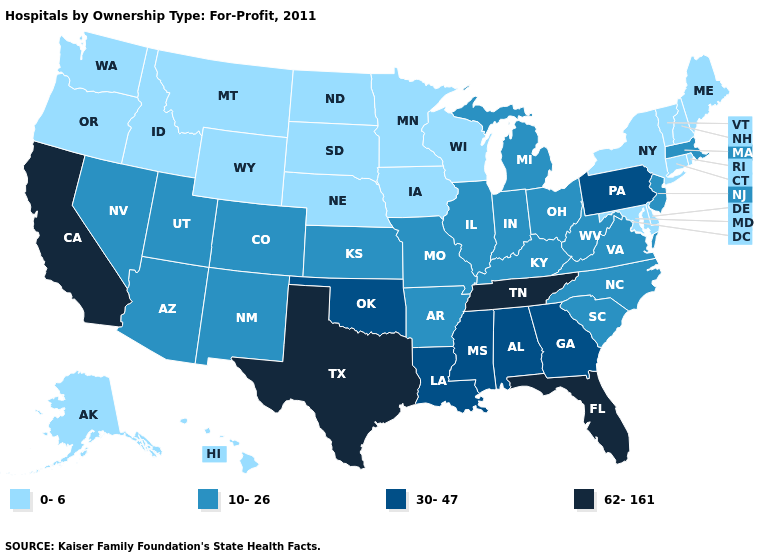Does Texas have the highest value in the USA?
Quick response, please. Yes. Name the states that have a value in the range 30-47?
Concise answer only. Alabama, Georgia, Louisiana, Mississippi, Oklahoma, Pennsylvania. Name the states that have a value in the range 62-161?
Keep it brief. California, Florida, Tennessee, Texas. What is the lowest value in the West?
Keep it brief. 0-6. What is the value of Maine?
Be succinct. 0-6. Is the legend a continuous bar?
Be succinct. No. Does the first symbol in the legend represent the smallest category?
Be succinct. Yes. Which states have the lowest value in the USA?
Quick response, please. Alaska, Connecticut, Delaware, Hawaii, Idaho, Iowa, Maine, Maryland, Minnesota, Montana, Nebraska, New Hampshire, New York, North Dakota, Oregon, Rhode Island, South Dakota, Vermont, Washington, Wisconsin, Wyoming. Does West Virginia have a lower value than Delaware?
Keep it brief. No. Is the legend a continuous bar?
Keep it brief. No. What is the value of Florida?
Concise answer only. 62-161. Does Idaho have the lowest value in the USA?
Be succinct. Yes. Name the states that have a value in the range 10-26?
Write a very short answer. Arizona, Arkansas, Colorado, Illinois, Indiana, Kansas, Kentucky, Massachusetts, Michigan, Missouri, Nevada, New Jersey, New Mexico, North Carolina, Ohio, South Carolina, Utah, Virginia, West Virginia. Name the states that have a value in the range 10-26?
Quick response, please. Arizona, Arkansas, Colorado, Illinois, Indiana, Kansas, Kentucky, Massachusetts, Michigan, Missouri, Nevada, New Jersey, New Mexico, North Carolina, Ohio, South Carolina, Utah, Virginia, West Virginia. Name the states that have a value in the range 10-26?
Short answer required. Arizona, Arkansas, Colorado, Illinois, Indiana, Kansas, Kentucky, Massachusetts, Michigan, Missouri, Nevada, New Jersey, New Mexico, North Carolina, Ohio, South Carolina, Utah, Virginia, West Virginia. 